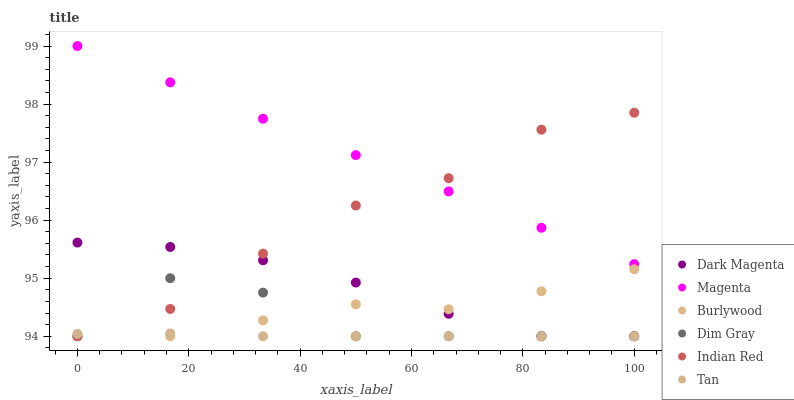Does Tan have the minimum area under the curve?
Answer yes or no. Yes. Does Magenta have the maximum area under the curve?
Answer yes or no. Yes. Does Dark Magenta have the minimum area under the curve?
Answer yes or no. No. Does Dark Magenta have the maximum area under the curve?
Answer yes or no. No. Is Magenta the smoothest?
Answer yes or no. Yes. Is Dim Gray the roughest?
Answer yes or no. Yes. Is Dark Magenta the smoothest?
Answer yes or no. No. Is Dark Magenta the roughest?
Answer yes or no. No. Does Dim Gray have the lowest value?
Answer yes or no. Yes. Does Magenta have the lowest value?
Answer yes or no. No. Does Magenta have the highest value?
Answer yes or no. Yes. Does Dark Magenta have the highest value?
Answer yes or no. No. Is Dim Gray less than Magenta?
Answer yes or no. Yes. Is Magenta greater than Dark Magenta?
Answer yes or no. Yes. Does Burlywood intersect Tan?
Answer yes or no. Yes. Is Burlywood less than Tan?
Answer yes or no. No. Is Burlywood greater than Tan?
Answer yes or no. No. Does Dim Gray intersect Magenta?
Answer yes or no. No. 